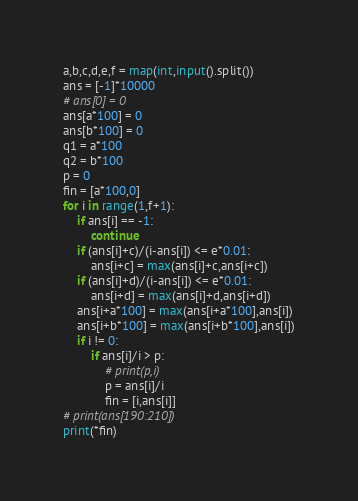<code> <loc_0><loc_0><loc_500><loc_500><_Python_>a,b,c,d,e,f = map(int,input().split())
ans = [-1]*10000
# ans[0] = 0
ans[a*100] = 0
ans[b*100] = 0
q1 = a*100
q2 = b*100
p = 0
fin = [a*100,0]
for i in range(1,f+1):
    if ans[i] == -1:
        continue
    if (ans[i]+c)/(i-ans[i]) <= e*0.01:
        ans[i+c] = max(ans[i]+c,ans[i+c])
    if (ans[i]+d)/(i-ans[i]) <= e*0.01:
        ans[i+d] = max(ans[i]+d,ans[i+d])
    ans[i+a*100] = max(ans[i+a*100],ans[i])
    ans[i+b*100] = max(ans[i+b*100],ans[i])
    if i != 0:
        if ans[i]/i > p:
            # print(p,i)
            p = ans[i]/i
            fin = [i,ans[i]]
# print(ans[190:210])
print(*fin)</code> 